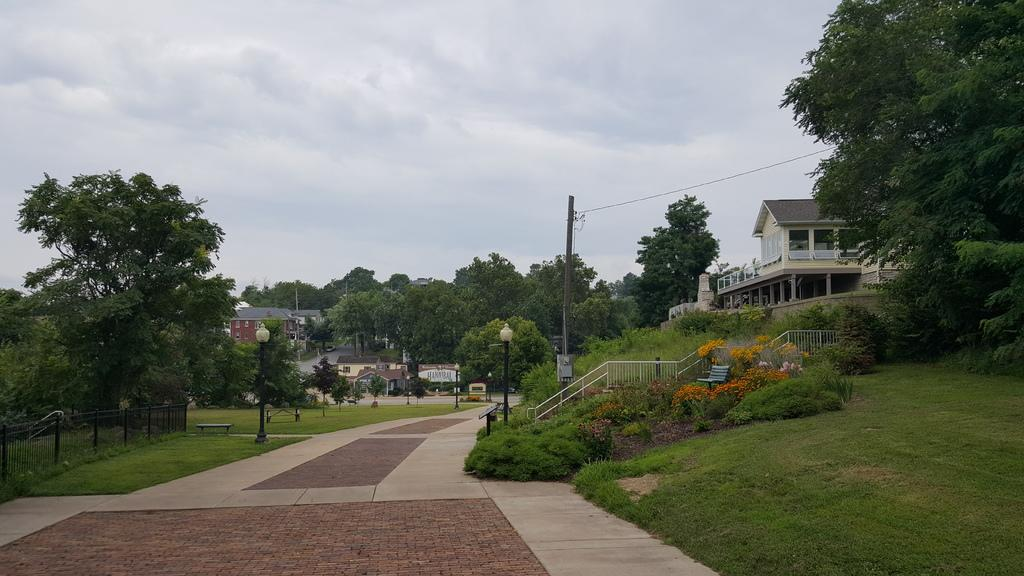What type of structures can be seen in the image? There are houses in the image. What type of vegetation is present in the image? There are plants, trees, and flowers in the image. What type of man-made objects can be seen in the image? There are light poles, handrails, and fencing in the image. What part of the natural environment is visible in the image? The sky is visible in the image. What type of payment is required to use the stove in the image? There is no stove present in the image, so no payment is required. What arithmetic problem can be solved using the numbers on the light poles in the image? There are no numbers on the light poles in the image, so no arithmetic problem can be solved. 